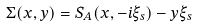<formula> <loc_0><loc_0><loc_500><loc_500>\Sigma ( x , y ) = S _ { A } ( x , - i \xi _ { s } ) - y \xi _ { s }</formula> 